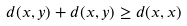Convert formula to latex. <formula><loc_0><loc_0><loc_500><loc_500>d ( x , y ) + d ( x , y ) \geq d ( x , x )</formula> 